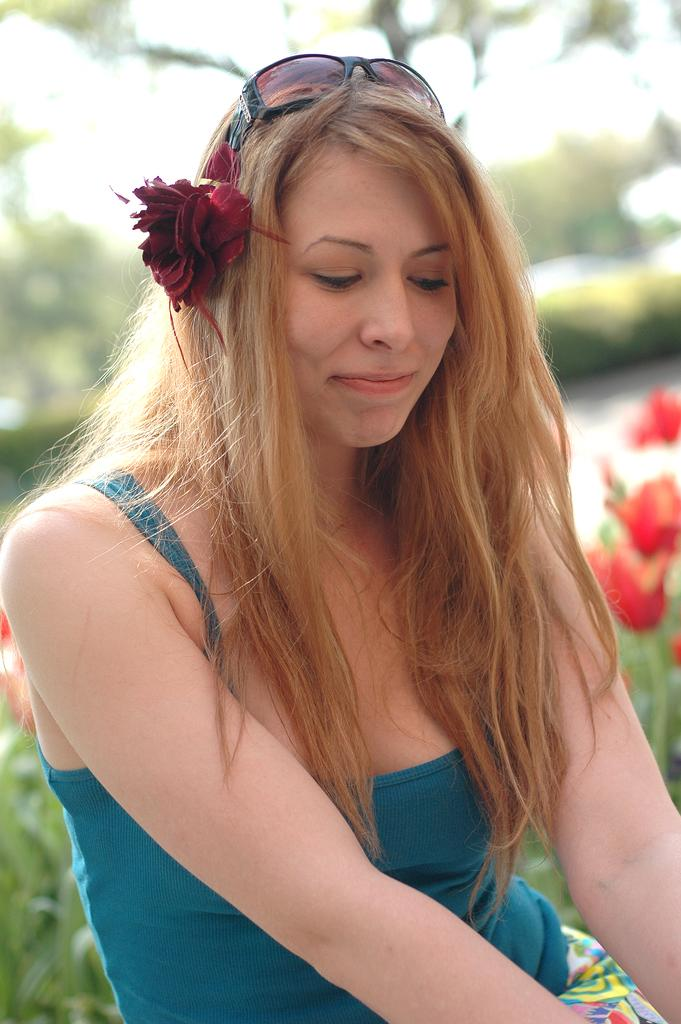Who is present in the image? There is a woman in the image. What can be seen in the background of the image? There are plants with flowers in the background of the image. How would you describe the background of the image? The background of the image is blurred. How many clovers can be seen in the image? There are no clovers present in the image. What type of hydrant is visible in the image? There is no hydrant present in the image. 